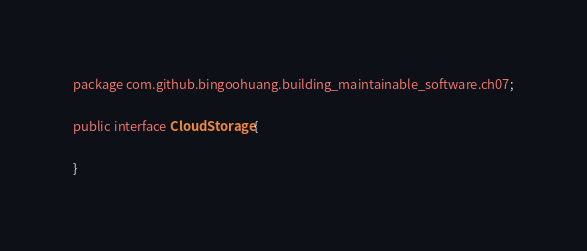<code> <loc_0><loc_0><loc_500><loc_500><_Java_>package com.github.bingoohuang.building_maintainable_software.ch07;

public interface CloudStorage {

}</code> 